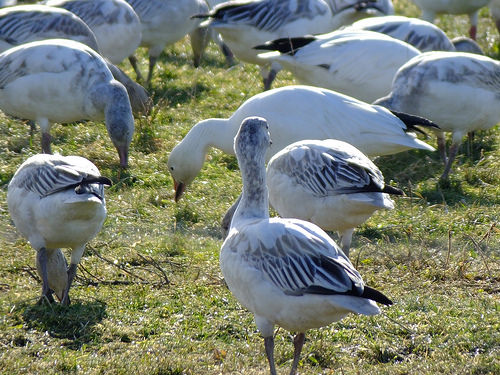<image>
Can you confirm if the animal is next to the branch? Yes. The animal is positioned adjacent to the branch, located nearby in the same general area. 